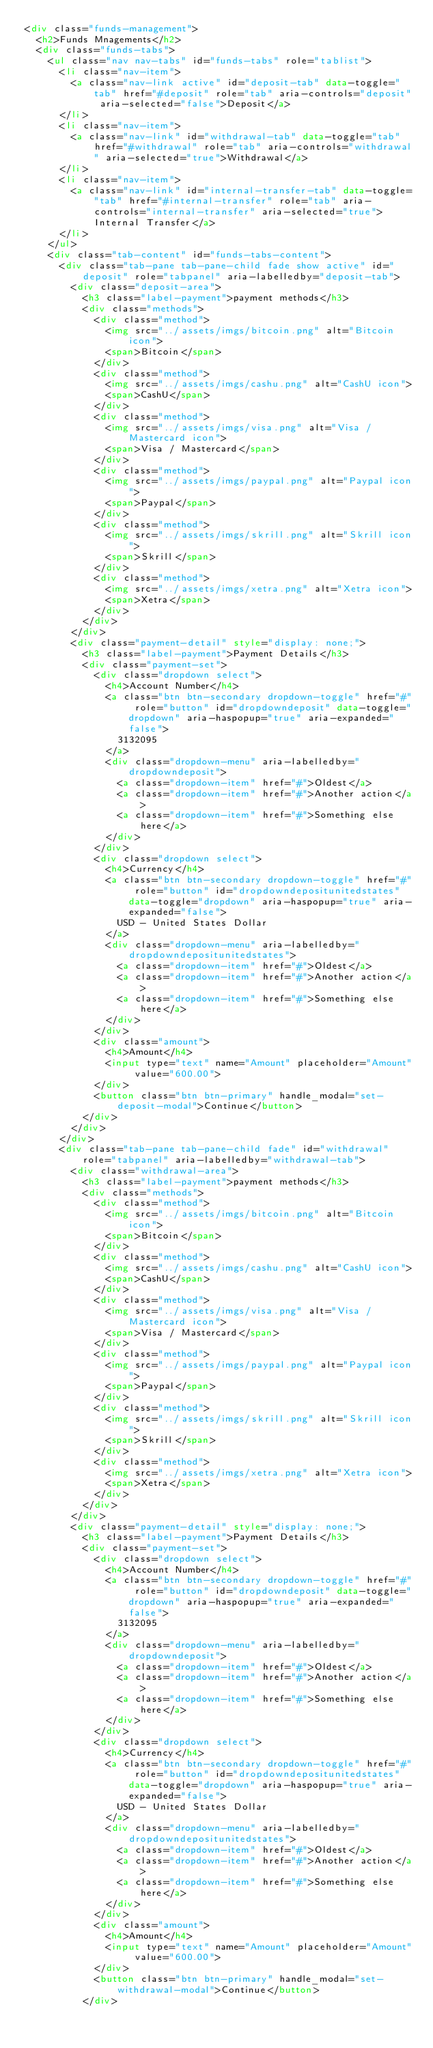<code> <loc_0><loc_0><loc_500><loc_500><_HTML_><div class="funds-management">
  <h2>Funds Mnagements</h2>
  <div class="funds-tabs">
    <ul class="nav nav-tabs" id="funds-tabs" role="tablist">
      <li class="nav-item">
        <a class="nav-link active" id="deposit-tab" data-toggle="tab" href="#deposit" role="tab" aria-controls="deposit" aria-selected="false">Deposit</a>
      </li>
      <li class="nav-item">
        <a class="nav-link" id="withdrawal-tab" data-toggle="tab" href="#withdrawal" role="tab" aria-controls="withdrawal" aria-selected="true">Withdrawal</a>
      </li>
      <li class="nav-item">
        <a class="nav-link" id="internal-transfer-tab" data-toggle="tab" href="#internal-transfer" role="tab" aria-controls="internal-transfer" aria-selected="true">Internal Transfer</a>
      </li>
    </ul>
    <div class="tab-content" id="funds-tabs-content">
      <div class="tab-pane tab-pane-child fade show active" id="deposit" role="tabpanel" aria-labelledby="deposit-tab">
        <div class="deposit-area">
          <h3 class="label-payment">payment methods</h3>
          <div class="methods">
            <div class="method">
              <img src="../assets/imgs/bitcoin.png" alt="Bitcoin icon">
              <span>Bitcoin</span>
            </div>
            <div class="method">
              <img src="../assets/imgs/cashu.png" alt="CashU icon">
              <span>CashU</span>
            </div>
            <div class="method">
              <img src="../assets/imgs/visa.png" alt="Visa / Mastercard icon">
              <span>Visa / Mastercard</span>
            </div>
            <div class="method">
              <img src="../assets/imgs/paypal.png" alt="Paypal icon">
              <span>Paypal</span>
            </div>
            <div class="method">
              <img src="../assets/imgs/skrill.png" alt="Skrill icon">
              <span>Skrill</span>
            </div>
            <div class="method">
              <img src="../assets/imgs/xetra.png" alt="Xetra icon">
              <span>Xetra</span>
            </div>
          </div>  
        </div>
        <div class="payment-detail" style="display: none;">
          <h3 class="label-payment">Payment Details</h3>
          <div class="payment-set">
            <div class="dropdown select">
              <h4>Account Number</h4>
              <a class="btn btn-secondary dropdown-toggle" href="#" role="button" id="dropdowndeposit" data-toggle="dropdown" aria-haspopup="true" aria-expanded="false">
                3132095
              </a>
              <div class="dropdown-menu" aria-labelledby="dropdowndeposit">
                <a class="dropdown-item" href="#">Oldest</a>
                <a class="dropdown-item" href="#">Another action</a>
                <a class="dropdown-item" href="#">Something else here</a>
              </div>
            </div>
            <div class="dropdown select">
              <h4>Currency</h4>
              <a class="btn btn-secondary dropdown-toggle" href="#" role="button" id="dropdowndepositunitedstates" data-toggle="dropdown" aria-haspopup="true" aria-expanded="false">
                USD - United States Dollar
              </a>
              <div class="dropdown-menu" aria-labelledby="dropdowndepositunitedstates">
                <a class="dropdown-item" href="#">Oldest</a>
                <a class="dropdown-item" href="#">Another action</a>
                <a class="dropdown-item" href="#">Something else here</a>
              </div>
            </div>
            <div class="amount">
              <h4>Amount</h4>
              <input type="text" name="Amount" placeholder="Amount" value="600.00">
            </div>
            <button class="btn btn-primary" handle_modal="set-deposit-modal">Continue</button>
          </div>
        </div>
      </div>
      <div class="tab-pane tab-pane-child fade" id="withdrawal" role="tabpanel" aria-labelledby="withdrawal-tab">
        <div class="withdrawal-area">
          <h3 class="label-payment">payment methods</h3>
          <div class="methods">
            <div class="method">
              <img src="../assets/imgs/bitcoin.png" alt="Bitcoin icon">
              <span>Bitcoin</span>
            </div>
            <div class="method">
              <img src="../assets/imgs/cashu.png" alt="CashU icon">
              <span>CashU</span>
            </div>
            <div class="method">
              <img src="../assets/imgs/visa.png" alt="Visa / Mastercard icon">
              <span>Visa / Mastercard</span>
            </div>
            <div class="method">
              <img src="../assets/imgs/paypal.png" alt="Paypal icon">
              <span>Paypal</span>
            </div>
            <div class="method">
              <img src="../assets/imgs/skrill.png" alt="Skrill icon">
              <span>Skrill</span>
            </div>
            <div class="method">
              <img src="../assets/imgs/xetra.png" alt="Xetra icon">
              <span>Xetra</span>
            </div>
          </div>
        </div>
        <div class="payment-detail" style="display: none;">
          <h3 class="label-payment">Payment Details</h3>
          <div class="payment-set">
            <div class="dropdown select">
              <h4>Account Number</h4>
              <a class="btn btn-secondary dropdown-toggle" href="#" role="button" id="dropdowndeposit" data-toggle="dropdown" aria-haspopup="true" aria-expanded="false">
                3132095
              </a>
              <div class="dropdown-menu" aria-labelledby="dropdowndeposit">
                <a class="dropdown-item" href="#">Oldest</a>
                <a class="dropdown-item" href="#">Another action</a>
                <a class="dropdown-item" href="#">Something else here</a>
              </div>
            </div>
            <div class="dropdown select">
              <h4>Currency</h4>
              <a class="btn btn-secondary dropdown-toggle" href="#" role="button" id="dropdowndepositunitedstates" data-toggle="dropdown" aria-haspopup="true" aria-expanded="false">
                USD - United States Dollar
              </a>
              <div class="dropdown-menu" aria-labelledby="dropdowndepositunitedstates">
                <a class="dropdown-item" href="#">Oldest</a>
                <a class="dropdown-item" href="#">Another action</a>
                <a class="dropdown-item" href="#">Something else here</a>
              </div>
            </div>
            <div class="amount">
              <h4>Amount</h4>
              <input type="text" name="Amount" placeholder="Amount" value="600.00">
            </div>
            <button class="btn btn-primary" handle_modal="set-withdrawal-modal">Continue</button>
          </div></code> 